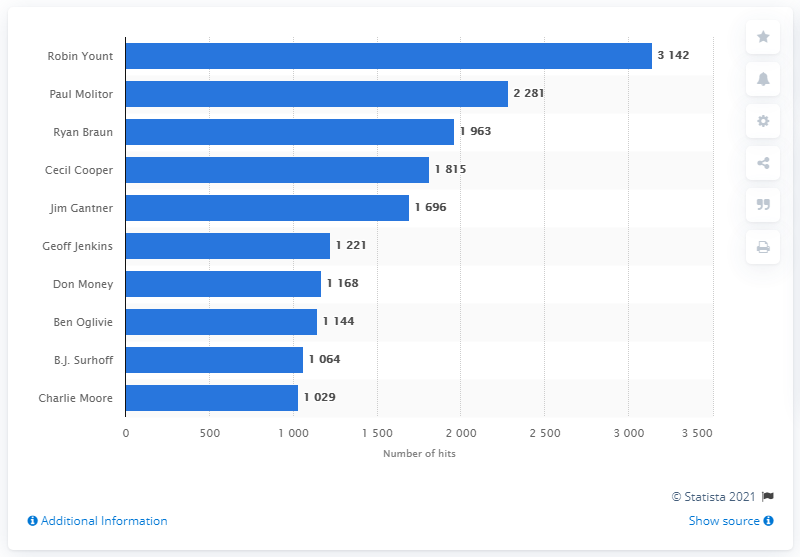Indicate a few pertinent items in this graphic. Robin Yount is the Milwaukee Brewers franchise player with the most hits in history. 